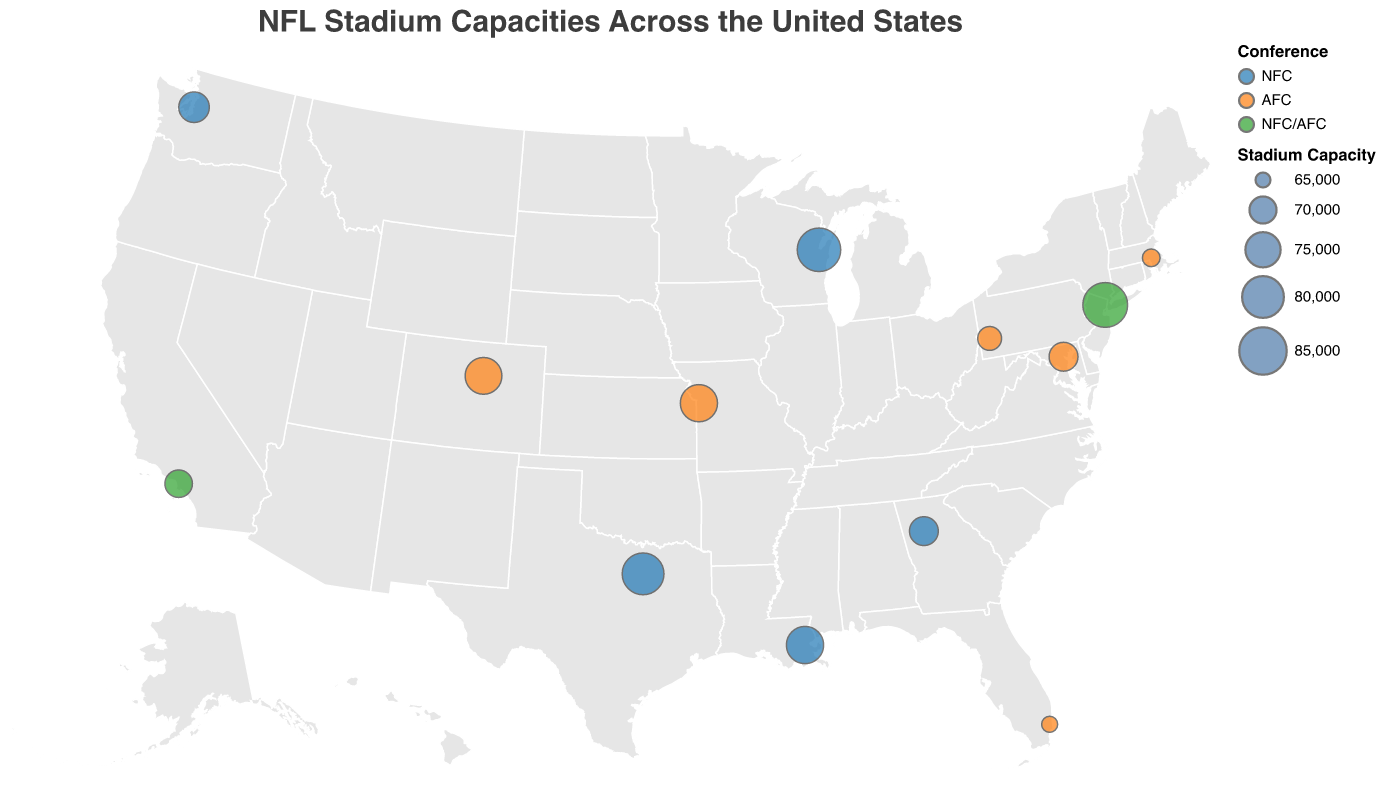Which stadium has the largest seating capacity? First, locate the circles representing stadiums. Look for the stadium with the largest circle, which corresponds to the highest seating capacity. Upon inspecting the circles, MetLife Stadium has the largest capacity.
Answer: MetLife Stadium In which state are the most stadiums located? Identify the location of each stadium by the state marker on the map. Count the stadiums in each state. After counting, you'll see there are two stadiums in California (SoFi Stadium and Levi's Stadium), but no state has more than California in this dataset.
Answer: California What is the seating capacity range shown in the legend? Look at the legend which details the mapping of circle sizes to seating capacities. It lists the range of seating capacities that the circles represent. From the legend, we see the capacity range is from 65,000 to 85,000.
Answer: 65,000 to 85,000 Which conference has more stadiums shown on the map, NFC or AFC? Examine the color coding of the circles. Check the legend to understand which colors represent the NFC and AFC. Count the number of circles in each color category. The NFC has 6 stadiums, and the AFC has 6 stadiums, resulting in a tie.
Answer: Tie (6 each) Which stadium is located furthest to the west? Identify the stadium that is located furthest to the left (west) on the map based on its longitude. Lumen Field in Seattle, WA, is the furthest west.
Answer: Lumen Field How many stadiums have a seating capacity over 75,000? By looking at the size and tooltip information for each circle, count how many stadiums have a seating capacity greater than 75,000. These stadiums are Lambeau Field, MetLife Stadium, AT&T Stadium, Arrowhead Stadium, and Caesars Superdome, totaling 5 stadiums.
Answer: 5 Which stadium is located in the most southern point of the map? Check the latitude coordinates of the stadiums and find the one with the smallest latitude (southernmost). Hard Rock Stadium in Miami Gardens, FL, is the most southern.
Answer: Hard Rock Stadium Compare the seating capacities of Lumen Field and Empower Field at Mile High. Which one has a larger capacity? Find the circles representing Lumen Field and Empower Field at Mile High. Refer to the tooltips or legend sizes to compare their capacities. Lumen Field has a capacity of 72,000, which is less than Empower Field at Mile High's 76,125.
Answer: Empower Field at Mile High What is the average seating capacity of the NFC stadiums shown? Identify all the NFC stadiums' seating capacities: Lambeau Field (81,441), AT&T Stadium (80,000), Lumen Field (72,000), Mercedes-Benz Stadium (71,000), and Caesars Superdome (76,416). Sum these capacities and divide by the number of NFC stadiums. The total is 380,857 / 5 = 76,171.4.
Answer: 76,171.4 